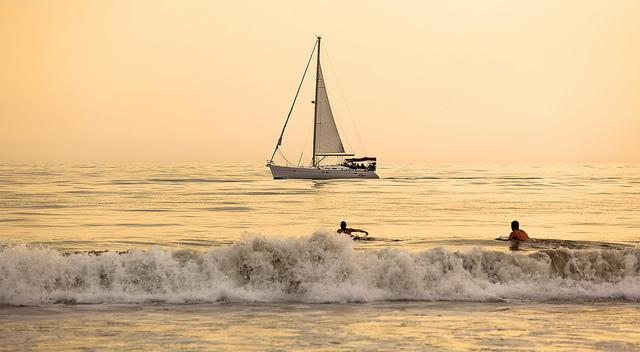How is this boat powered?

Choices:
A) motor
B) wind
C) whale
D) coal wind 